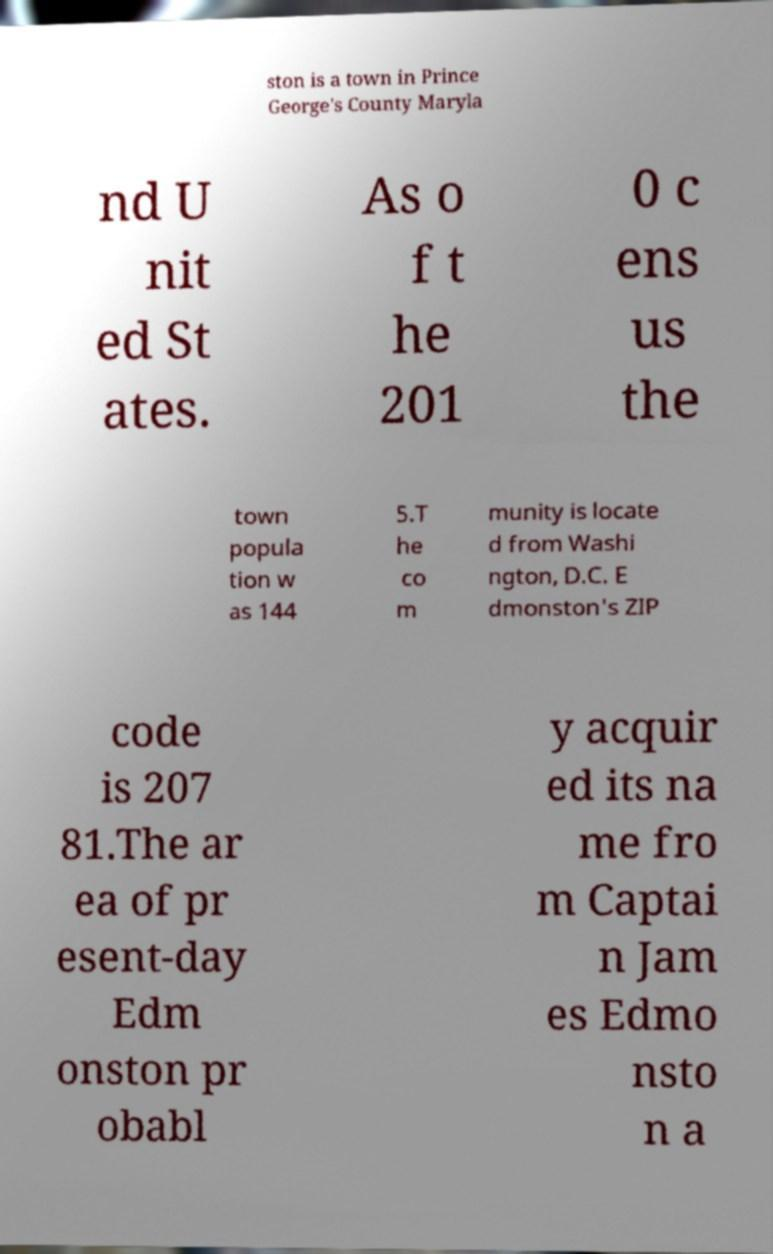For documentation purposes, I need the text within this image transcribed. Could you provide that? ston is a town in Prince George's County Maryla nd U nit ed St ates. As o f t he 201 0 c ens us the town popula tion w as 144 5.T he co m munity is locate d from Washi ngton, D.C. E dmonston's ZIP code is 207 81.The ar ea of pr esent-day Edm onston pr obabl y acquir ed its na me fro m Captai n Jam es Edmo nsto n a 